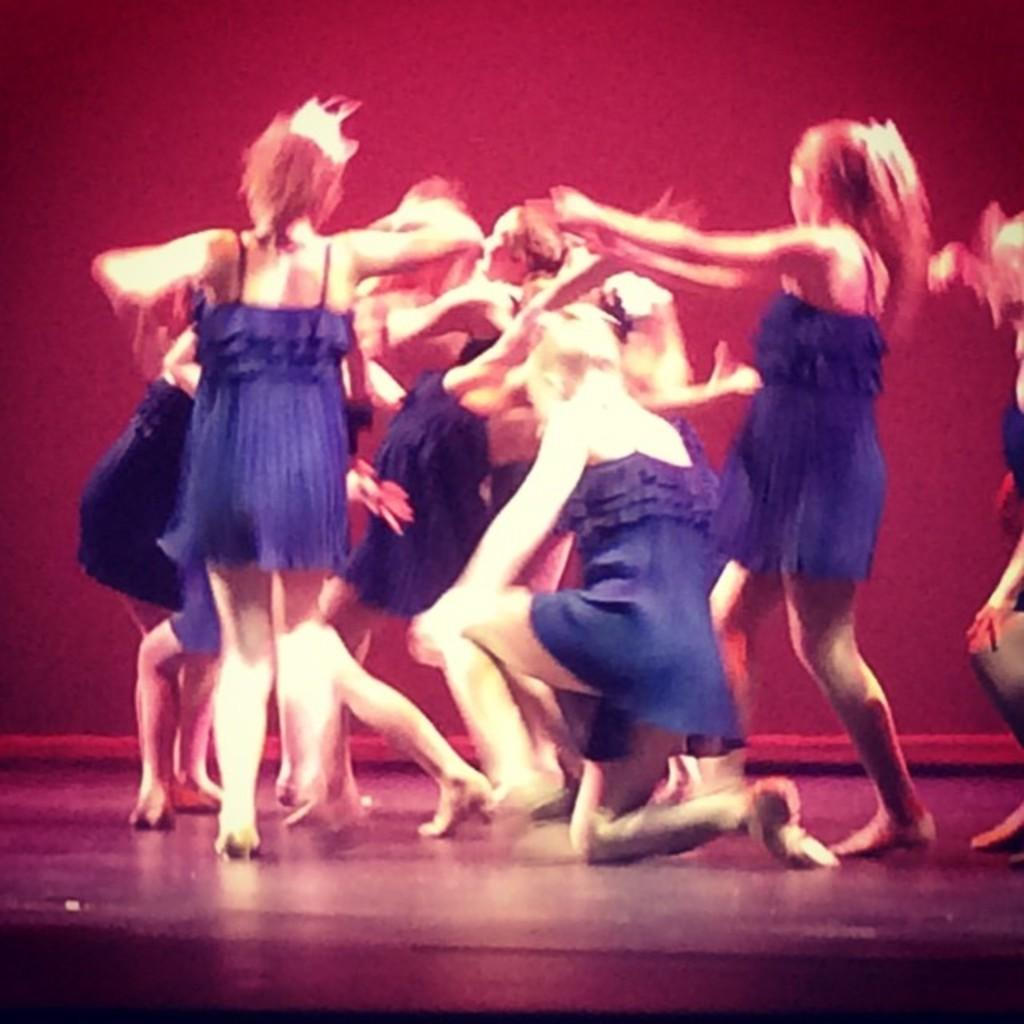What is happening in the image? There is a group of women in the image, and they are dancing. Where are the women dancing? The women are on a stage. What type of limit or border is present in the image? There is no limit or border mentioned or visible in the image. 